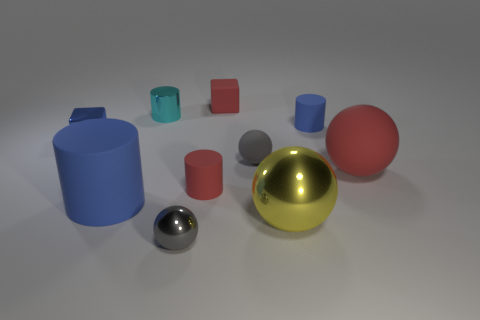Subtract all green cylinders. How many gray balls are left? 2 Subtract 2 cylinders. How many cylinders are left? 2 Subtract all yellow balls. How many balls are left? 3 Subtract all tiny shiny spheres. How many spheres are left? 3 Subtract all purple spheres. Subtract all green blocks. How many spheres are left? 4 Subtract all spheres. How many objects are left? 6 Add 8 red matte cylinders. How many red matte cylinders are left? 9 Add 3 yellow shiny spheres. How many yellow shiny spheres exist? 4 Subtract 2 gray balls. How many objects are left? 8 Subtract all tiny blue things. Subtract all matte cubes. How many objects are left? 7 